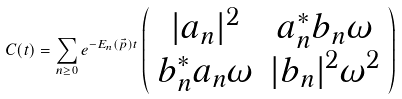<formula> <loc_0><loc_0><loc_500><loc_500>C ( t ) = \sum _ { n \geq 0 } e ^ { - E _ { n } ( \vec { p } ) t } \left ( \begin{array} { c c } | a _ { n } | ^ { 2 } & a ^ { \ast } _ { n } b _ { n } \omega \\ b ^ { \ast } _ { n } a _ { n } \omega & | b _ { n } | ^ { 2 } \omega ^ { 2 } \end{array} \right )</formula> 